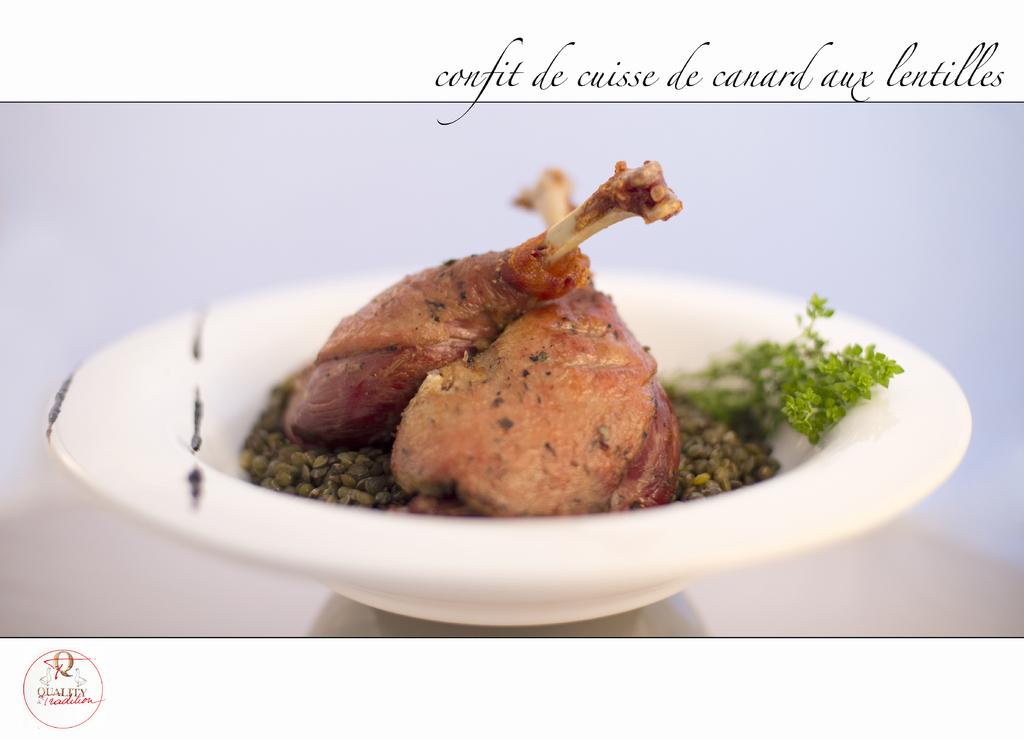What is in the bowl that is visible in the image? There is a bowl filled with food items in the image. What else can be seen in the image besides the bowl? There is text visible on the top of the image. Can you see a boat in the image? No, there is no boat present in the image. Is there a kitty playing with a robin in the image? No, there are no animals present in the image, and therefore no such interaction can be observed. 